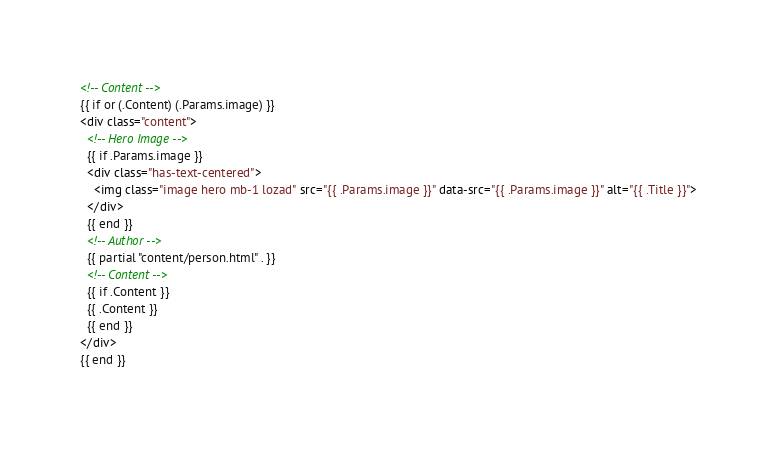Convert code to text. <code><loc_0><loc_0><loc_500><loc_500><_HTML_><!-- Content -->
{{ if or (.Content) (.Params.image) }}
<div class="content">
  <!-- Hero Image -->
  {{ if .Params.image }}
  <div class="has-text-centered">
    <img class="image hero mb-1 lozad" src="{{ .Params.image }}" data-src="{{ .Params.image }}" alt="{{ .Title }}">
  </div>
  {{ end }}
  <!-- Author -->
  {{ partial "content/person.html" . }}
  <!-- Content -->
  {{ if .Content }}
  {{ .Content }}
  {{ end }}
</div>
{{ end }}
</code> 